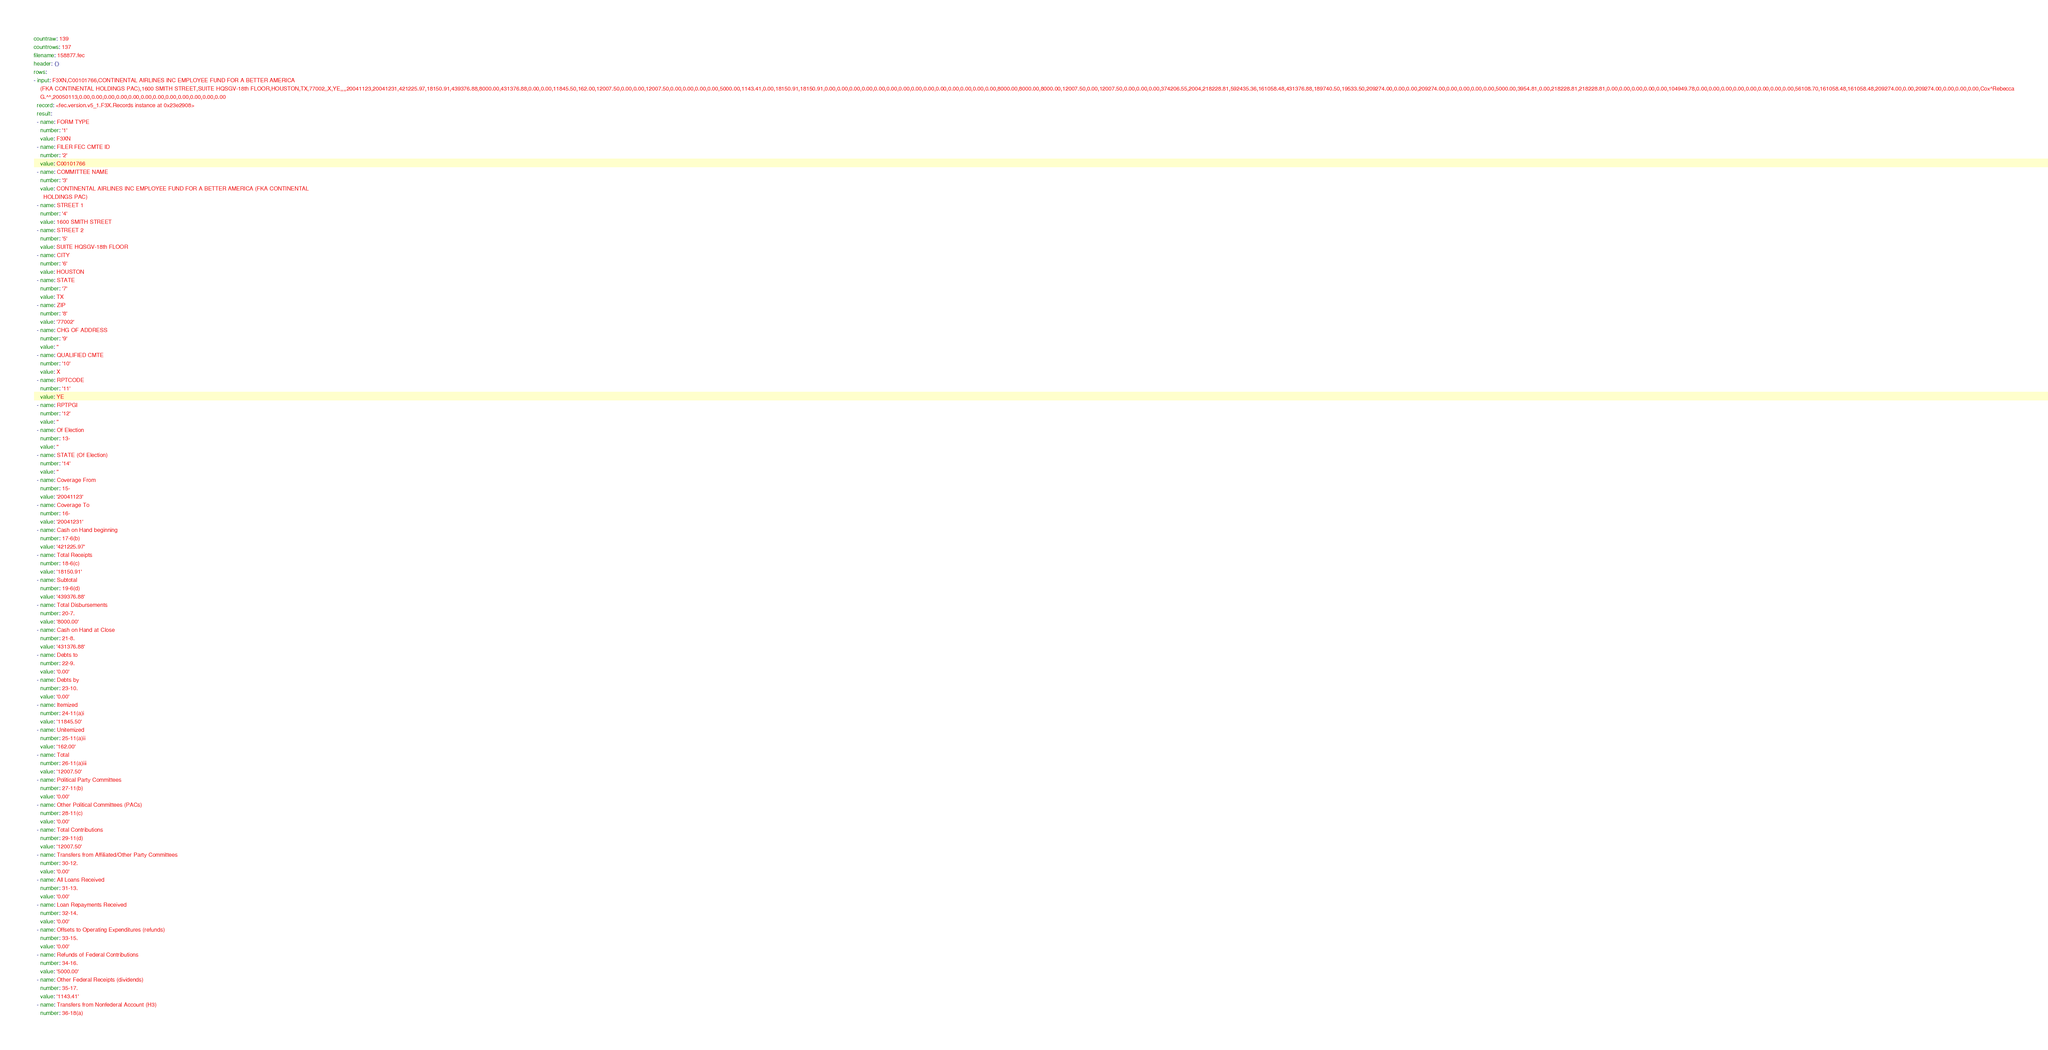Convert code to text. <code><loc_0><loc_0><loc_500><loc_500><_YAML_>countraw: 139
countrows: 137
filename: 158877.fec
header: {}
rows:
- input: F3XN,C00101766,CONTINENTAL AIRLINES INC EMPLOYEE FUND FOR A BETTER AMERICA
    (FKA CONTINENTAL HOLDINGS PAC),1600 SMITH STREET,SUITE HQSGV-18th FLOOR,HOUSTON,TX,77002,,X,YE,,,,20041123,20041231,421225.97,18150.91,439376.88,8000.00,431376.88,0.00,0.00,11845.50,162.00,12007.50,0.00,0.00,12007.50,0.00,0.00,0.00,0.00,5000.00,1143.41,0.00,18150.91,18150.91,0.00,0.00,0.00,0.00,0.00,0.00,0.00,0.00,0.00,0.00,0.00,0.00,0.00,0.00,8000.00,8000.00,8000.00,12007.50,0.00,12007.50,0.00,0.00,0.00,374206.55,2004,218228.81,592435.36,161058.48,431376.88,189740.50,19533.50,209274.00,0.00,0.00,209274.00,0.00,0.00,0.00,0.00,5000.00,3954.81,0.00,218228.81,218228.81,0.00,0.00,0.00,0.00,0.00,104949.78,0.00,0.00,0.00,0.00,0.00,0.00,0.00,0.00,56108.70,161058.48,161058.48,209274.00,0.00,209274.00,0.00,0.00,0.00,Cox^Rebecca
    G.^^,20050113,0.00,0.00,0.00,0.00,0.00,0.00,0.00,0.00,0.00,0.00,0.00,0.00
  record: <fec.version.v5_1.F3X.Records instance at 0x23e2908>
  result:
  - name: FORM TYPE
    number: '1'
    value: F3XN
  - name: FILER FEC CMTE ID
    number: '2'
    value: C00101766
  - name: COMMITTEE NAME
    number: '3'
    value: CONTINENTAL AIRLINES INC EMPLOYEE FUND FOR A BETTER AMERICA (FKA CONTINENTAL
      HOLDINGS PAC)
  - name: STREET 1
    number: '4'
    value: 1600 SMITH STREET
  - name: STREET 2
    number: '5'
    value: SUITE HQSGV-18th FLOOR
  - name: CITY
    number: '6'
    value: HOUSTON
  - name: STATE
    number: '7'
    value: TX
  - name: ZIP
    number: '8'
    value: '77002'
  - name: CHG OF ADDRESS
    number: '9'
    value: ''
  - name: QUALIFIED CMTE
    number: '10'
    value: X
  - name: RPTCODE
    number: '11'
    value: YE
  - name: RPTPGI
    number: '12'
    value: ''
  - name: Of Election
    number: 13-
    value: ''
  - name: STATE (Of Election)
    number: '14'
    value: ''
  - name: Coverage From
    number: 15-
    value: '20041123'
  - name: Coverage To
    number: 16-
    value: '20041231'
  - name: Cash on Hand beginning
    number: 17-6(b)
    value: '421225.97'
  - name: Total Receipts
    number: 18-6(c)
    value: '18150.91'
  - name: Subtotal
    number: 19-6(d)
    value: '439376.88'
  - name: Total Disbursements
    number: 20-7.
    value: '8000.00'
  - name: Cash on Hand at Close
    number: 21-8.
    value: '431376.88'
  - name: Debts to
    number: 22-9.
    value: '0.00'
  - name: Debts by
    number: 23-10.
    value: '0.00'
  - name: Itemized
    number: 24-11(a)i
    value: '11845.50'
  - name: Unitemized
    number: 25-11(a)ii
    value: '162.00'
  - name: Total
    number: 26-11(a)iii
    value: '12007.50'
  - name: Political Party Committees
    number: 27-11(b)
    value: '0.00'
  - name: Other Political Committees (PACs)
    number: 28-11(c)
    value: '0.00'
  - name: Total Contributions
    number: 29-11(d)
    value: '12007.50'
  - name: Transfers from Affiliated/Other Party Committees
    number: 30-12.
    value: '0.00'
  - name: All Loans Received
    number: 31-13.
    value: '0.00'
  - name: Loan Repayments Received
    number: 32-14.
    value: '0.00'
  - name: Offsets to Operating Expenditures (refunds)
    number: 33-15.
    value: '0.00'
  - name: Refunds of Federal Contributions
    number: 34-16.
    value: '5000.00'
  - name: Other Federal Receipts (dividends)
    number: 35-17.
    value: '1143.41'
  - name: Transfers from Nonfederal Account (H3)
    number: 36-18(a)</code> 